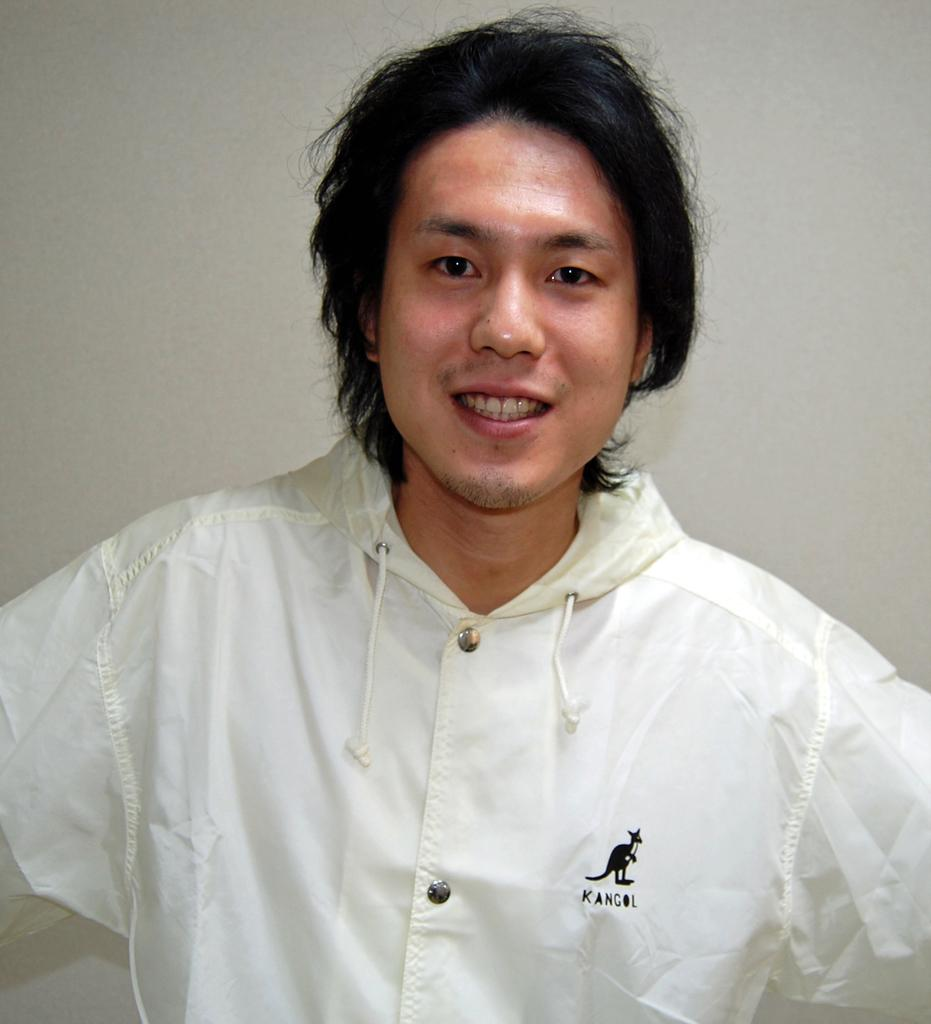What is present in the image? There is a person in the image. How is the person's expression? The person is smiling. What can be seen in the background of the image? There is a wall in the background of the image. What type of can is visible on the floor in the image? There is no can present in the image, and the floor is not mentioned in the provided facts. 